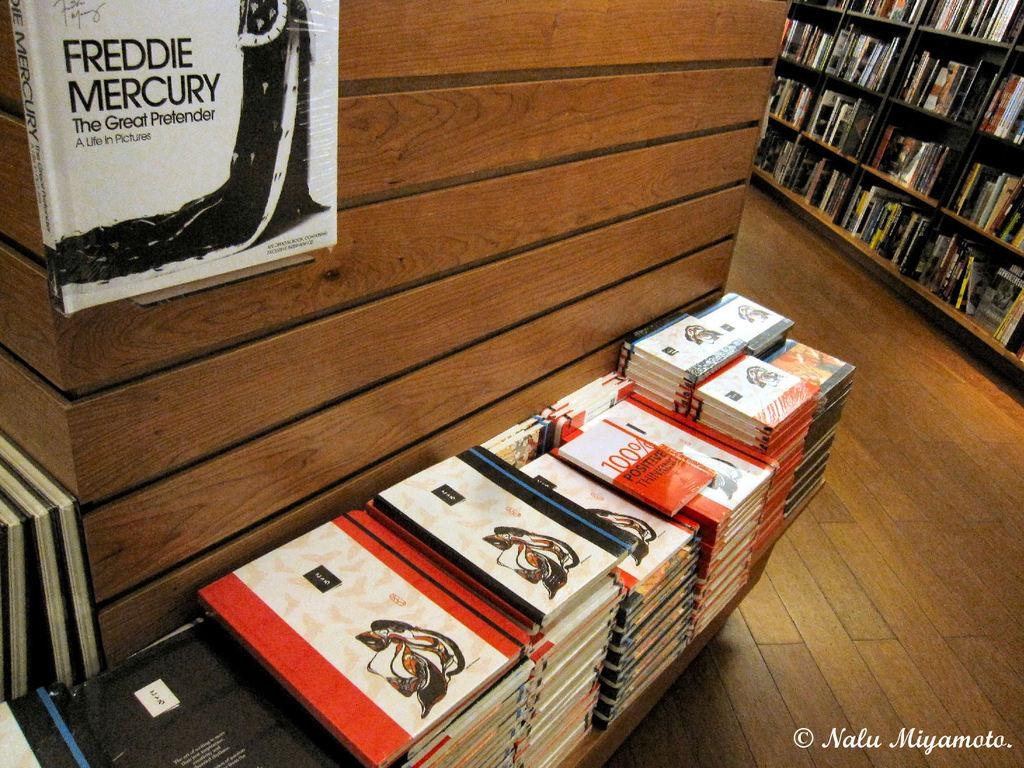What objects can be seen near the wooden pillar in the foreground? There are books near a wooden pillar in the foreground. Can you describe the position of the book at the top in the foreground? There is another book at the top in the foreground. What type of surface is visible in the background? There is floor visible in the background. Where are the other books located in the image? There are books in a rack in the background. How many planes can be seen flying over the books in the image? There are no planes visible in the image; it only features books and a wooden pillar. Are there any giants present in the image? There are no giants present in the image; it only features books and a wooden pillar. 